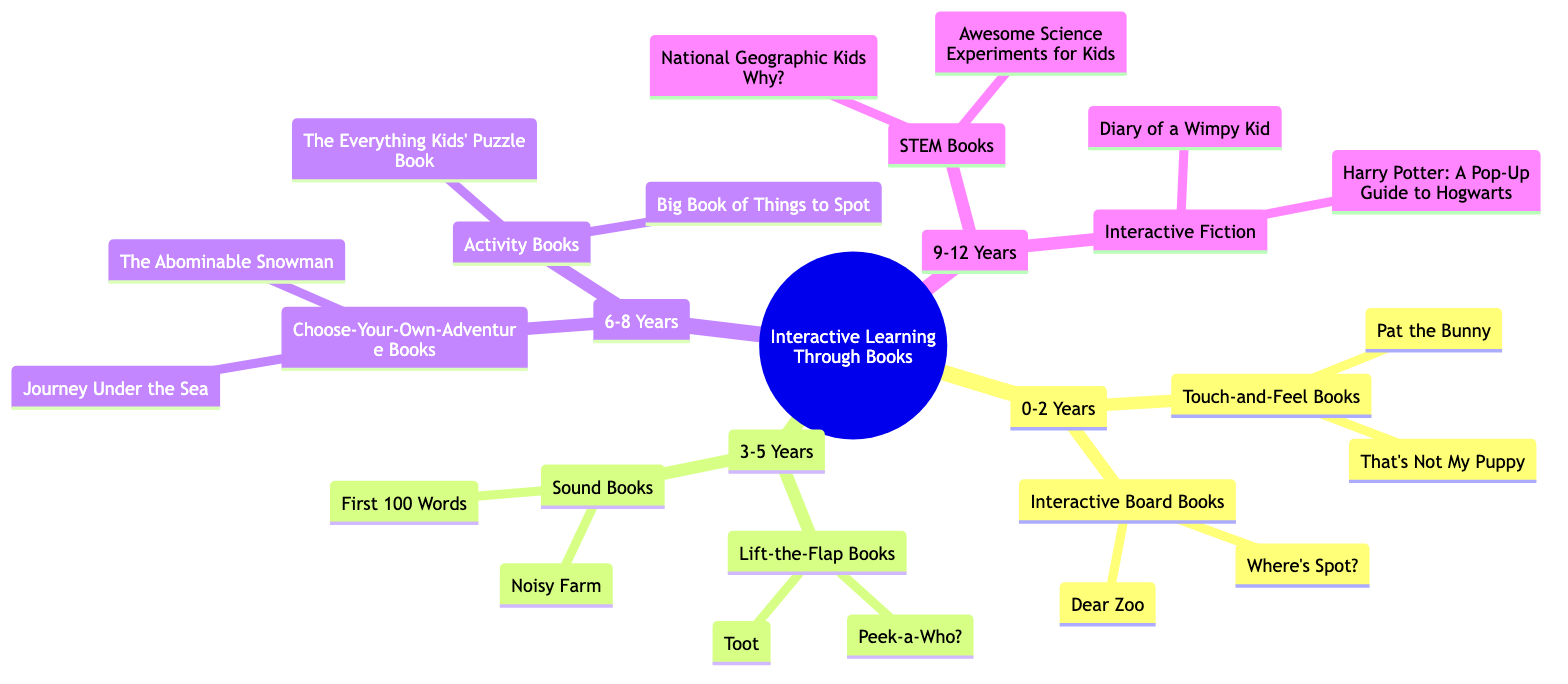What age group has interactive board books? According to the diagram, interactive board books are listed under the "0-2 Years" age group.
Answer: 0-2 Years How many types of books are listed for the 3-5 years age group? In the diagram, there are two types of books for the 3-5 years age group: Lift-the-Flap Books and Sound Books.
Answer: 2 What is the title of a touch-and-feel book? The diagram lists "Pat the Bunny by Dorothy Kunhardt" as one of the titles under touch-and-feel books for the 0-2 years age group.
Answer: Pat the Bunny Which age group has choose-your-own-adventure books? The choose-your-own-adventure books are categorized under the 6-8 years age group in the diagram.
Answer: 6-8 Years What is the relationship between "9-12 Years" and "STEM Books"? The "9-12 Years" category contains "STEM Books", indicating that it is a sub-category of that age group.
Answer: Sub-category How many total titles are listed under the 6-8 years age group? The diagram shows two types of books under the 6-8 years age group, each with two titles, resulting in a total of four titles.
Answer: 4 What type of books does the 3-5 years age group have that involve sound? The diagram identifies "Sound Books" as the category for the 3-5 years age group that involves sound.
Answer: Sound Books Which type of books includes "Diary of a Wimpy Kid"? "Diary of a Wimpy Kid" is included under the category of "Interactive Fiction" for the 9-12 years age group.
Answer: Interactive Fiction 